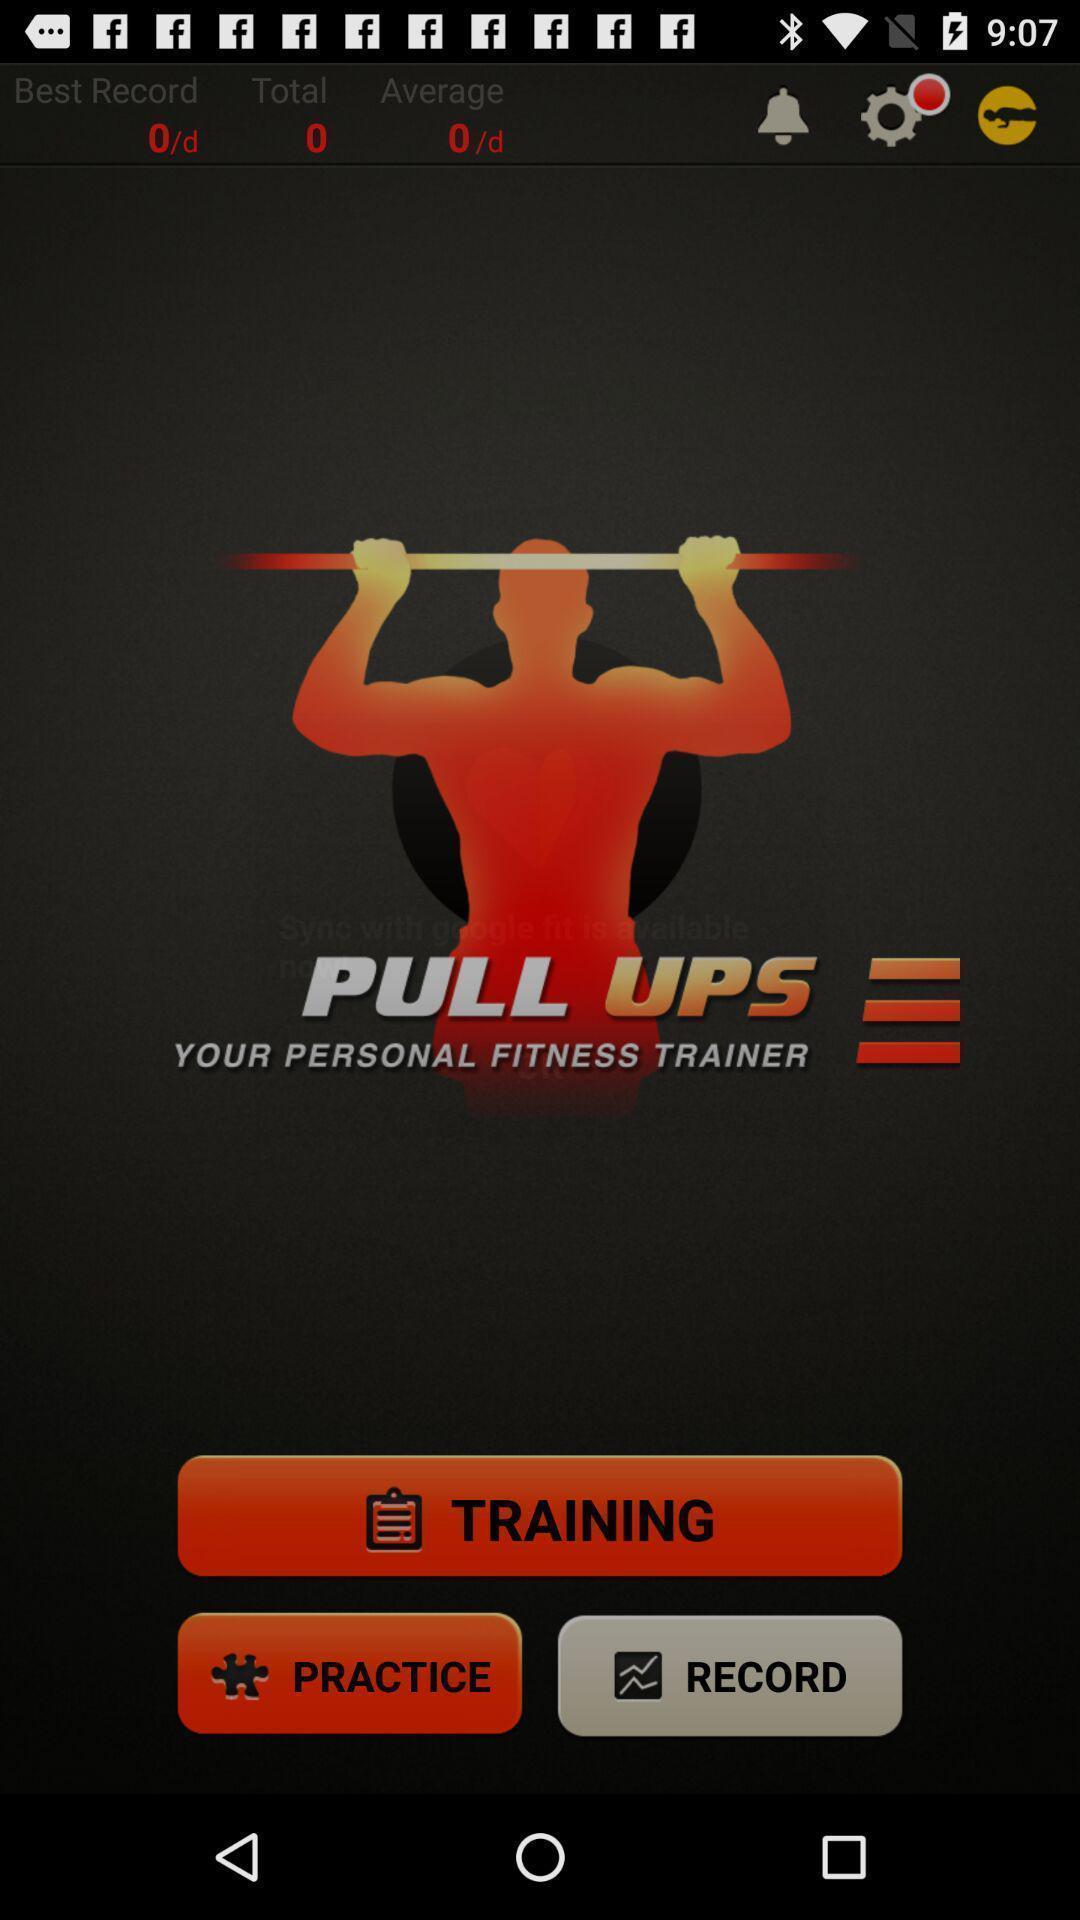Tell me about the visual elements in this screen capture. Workout training page. 